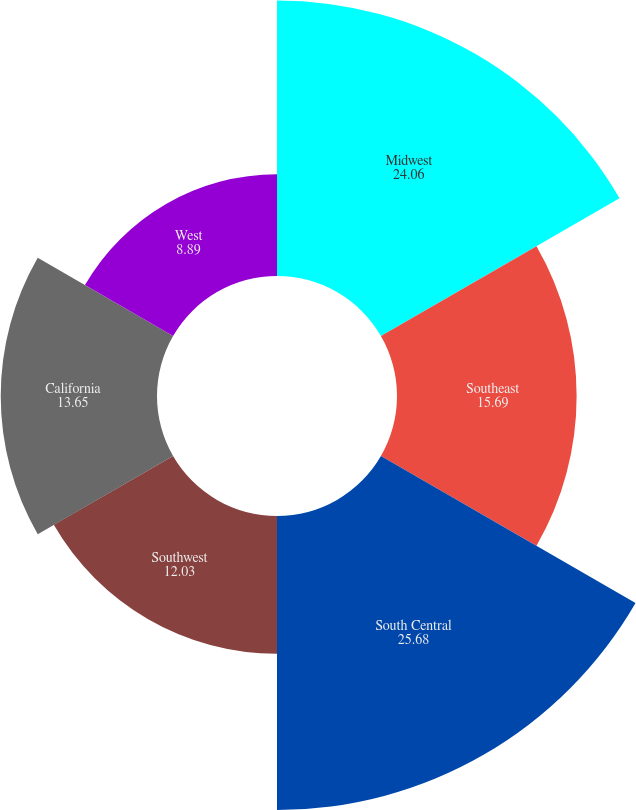Convert chart to OTSL. <chart><loc_0><loc_0><loc_500><loc_500><pie_chart><fcel>Midwest<fcel>Southeast<fcel>South Central<fcel>Southwest<fcel>California<fcel>West<nl><fcel>24.06%<fcel>15.69%<fcel>25.68%<fcel>12.03%<fcel>13.65%<fcel>8.89%<nl></chart> 